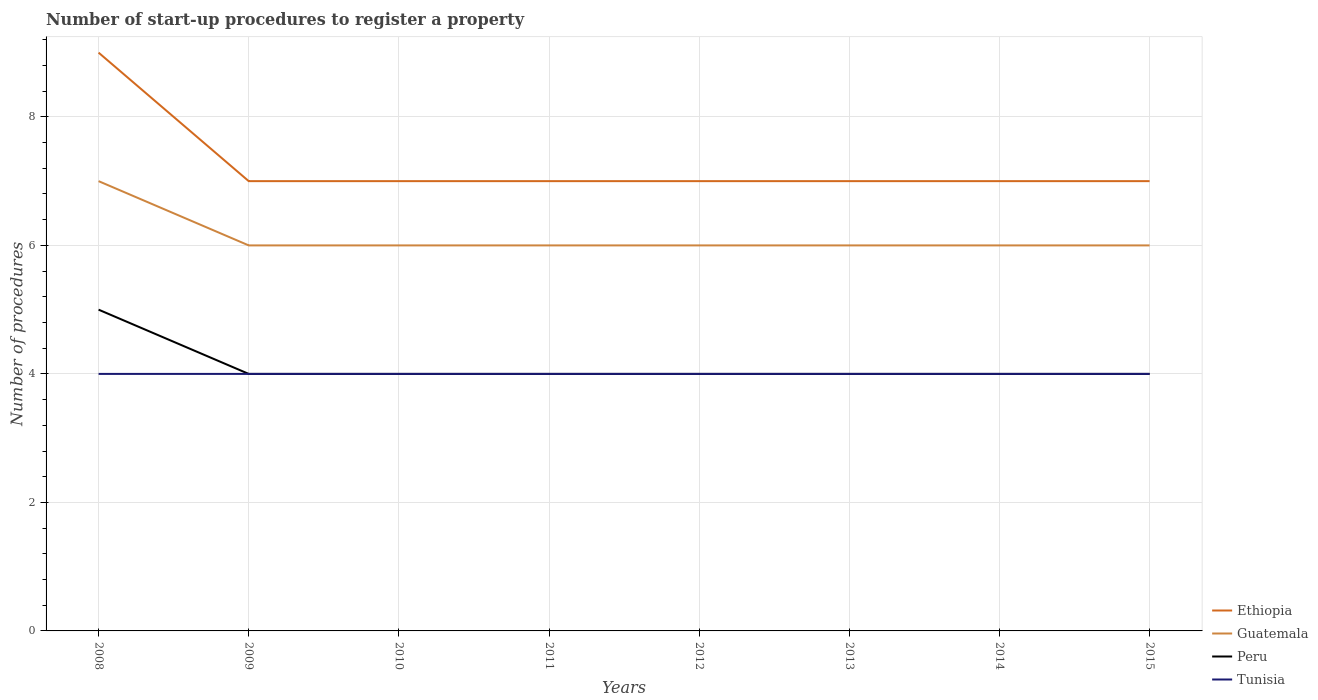How many different coloured lines are there?
Offer a terse response. 4. Across all years, what is the maximum number of procedures required to register a property in Tunisia?
Your answer should be compact. 4. What is the total number of procedures required to register a property in Ethiopia in the graph?
Give a very brief answer. 0. What is the difference between the highest and the second highest number of procedures required to register a property in Guatemala?
Your answer should be compact. 1. What is the difference between the highest and the lowest number of procedures required to register a property in Peru?
Offer a very short reply. 1. Is the number of procedures required to register a property in Guatemala strictly greater than the number of procedures required to register a property in Ethiopia over the years?
Offer a very short reply. Yes. What is the difference between two consecutive major ticks on the Y-axis?
Your response must be concise. 2. Are the values on the major ticks of Y-axis written in scientific E-notation?
Make the answer very short. No. Does the graph contain any zero values?
Offer a terse response. No. Does the graph contain grids?
Offer a very short reply. Yes. Where does the legend appear in the graph?
Your answer should be very brief. Bottom right. What is the title of the graph?
Your response must be concise. Number of start-up procedures to register a property. What is the label or title of the X-axis?
Keep it short and to the point. Years. What is the label or title of the Y-axis?
Provide a short and direct response. Number of procedures. What is the Number of procedures of Guatemala in 2008?
Ensure brevity in your answer.  7. What is the Number of procedures in Tunisia in 2008?
Keep it short and to the point. 4. What is the Number of procedures in Ethiopia in 2009?
Offer a very short reply. 7. What is the Number of procedures in Peru in 2009?
Give a very brief answer. 4. What is the Number of procedures in Tunisia in 2009?
Provide a short and direct response. 4. What is the Number of procedures in Guatemala in 2011?
Your answer should be compact. 6. What is the Number of procedures in Ethiopia in 2013?
Offer a very short reply. 7. What is the Number of procedures in Peru in 2013?
Keep it short and to the point. 4. What is the Number of procedures of Guatemala in 2014?
Offer a very short reply. 6. What is the Number of procedures in Tunisia in 2014?
Keep it short and to the point. 4. What is the Number of procedures in Ethiopia in 2015?
Your answer should be very brief. 7. What is the Number of procedures of Guatemala in 2015?
Keep it short and to the point. 6. Across all years, what is the maximum Number of procedures of Ethiopia?
Offer a terse response. 9. Across all years, what is the maximum Number of procedures in Tunisia?
Your answer should be very brief. 4. Across all years, what is the minimum Number of procedures of Ethiopia?
Offer a terse response. 7. Across all years, what is the minimum Number of procedures of Tunisia?
Keep it short and to the point. 4. What is the total Number of procedures in Ethiopia in the graph?
Ensure brevity in your answer.  58. What is the total Number of procedures of Peru in the graph?
Your response must be concise. 33. What is the total Number of procedures in Tunisia in the graph?
Provide a succinct answer. 32. What is the difference between the Number of procedures in Ethiopia in 2008 and that in 2009?
Ensure brevity in your answer.  2. What is the difference between the Number of procedures in Tunisia in 2008 and that in 2009?
Keep it short and to the point. 0. What is the difference between the Number of procedures in Ethiopia in 2008 and that in 2010?
Your answer should be very brief. 2. What is the difference between the Number of procedures in Peru in 2008 and that in 2011?
Provide a short and direct response. 1. What is the difference between the Number of procedures in Tunisia in 2008 and that in 2011?
Your answer should be very brief. 0. What is the difference between the Number of procedures in Guatemala in 2008 and that in 2012?
Give a very brief answer. 1. What is the difference between the Number of procedures of Tunisia in 2008 and that in 2012?
Provide a succinct answer. 0. What is the difference between the Number of procedures in Guatemala in 2008 and that in 2013?
Make the answer very short. 1. What is the difference between the Number of procedures of Peru in 2008 and that in 2013?
Your answer should be compact. 1. What is the difference between the Number of procedures in Guatemala in 2009 and that in 2010?
Give a very brief answer. 0. What is the difference between the Number of procedures of Peru in 2009 and that in 2010?
Your answer should be very brief. 0. What is the difference between the Number of procedures in Tunisia in 2009 and that in 2010?
Offer a very short reply. 0. What is the difference between the Number of procedures in Guatemala in 2009 and that in 2011?
Your answer should be very brief. 0. What is the difference between the Number of procedures of Ethiopia in 2009 and that in 2012?
Offer a terse response. 0. What is the difference between the Number of procedures of Tunisia in 2009 and that in 2012?
Your response must be concise. 0. What is the difference between the Number of procedures in Guatemala in 2009 and that in 2013?
Your answer should be very brief. 0. What is the difference between the Number of procedures in Guatemala in 2009 and that in 2014?
Keep it short and to the point. 0. What is the difference between the Number of procedures of Peru in 2009 and that in 2014?
Your answer should be compact. 0. What is the difference between the Number of procedures of Tunisia in 2009 and that in 2014?
Provide a short and direct response. 0. What is the difference between the Number of procedures in Ethiopia in 2009 and that in 2015?
Your response must be concise. 0. What is the difference between the Number of procedures in Peru in 2009 and that in 2015?
Give a very brief answer. 0. What is the difference between the Number of procedures in Tunisia in 2009 and that in 2015?
Offer a very short reply. 0. What is the difference between the Number of procedures of Ethiopia in 2010 and that in 2011?
Provide a succinct answer. 0. What is the difference between the Number of procedures of Guatemala in 2010 and that in 2011?
Your answer should be compact. 0. What is the difference between the Number of procedures of Peru in 2010 and that in 2011?
Offer a very short reply. 0. What is the difference between the Number of procedures in Guatemala in 2010 and that in 2012?
Ensure brevity in your answer.  0. What is the difference between the Number of procedures of Ethiopia in 2010 and that in 2013?
Ensure brevity in your answer.  0. What is the difference between the Number of procedures of Guatemala in 2010 and that in 2013?
Keep it short and to the point. 0. What is the difference between the Number of procedures in Tunisia in 2010 and that in 2013?
Your response must be concise. 0. What is the difference between the Number of procedures of Tunisia in 2010 and that in 2014?
Offer a terse response. 0. What is the difference between the Number of procedures in Peru in 2010 and that in 2015?
Ensure brevity in your answer.  0. What is the difference between the Number of procedures in Tunisia in 2010 and that in 2015?
Your answer should be compact. 0. What is the difference between the Number of procedures of Ethiopia in 2011 and that in 2012?
Your answer should be very brief. 0. What is the difference between the Number of procedures in Peru in 2011 and that in 2013?
Provide a short and direct response. 0. What is the difference between the Number of procedures of Ethiopia in 2011 and that in 2014?
Give a very brief answer. 0. What is the difference between the Number of procedures in Guatemala in 2011 and that in 2014?
Offer a terse response. 0. What is the difference between the Number of procedures of Peru in 2011 and that in 2014?
Give a very brief answer. 0. What is the difference between the Number of procedures of Ethiopia in 2011 and that in 2015?
Your answer should be compact. 0. What is the difference between the Number of procedures of Tunisia in 2011 and that in 2015?
Keep it short and to the point. 0. What is the difference between the Number of procedures of Guatemala in 2012 and that in 2013?
Your answer should be compact. 0. What is the difference between the Number of procedures in Tunisia in 2012 and that in 2013?
Your response must be concise. 0. What is the difference between the Number of procedures in Guatemala in 2012 and that in 2014?
Provide a short and direct response. 0. What is the difference between the Number of procedures in Ethiopia in 2012 and that in 2015?
Offer a very short reply. 0. What is the difference between the Number of procedures of Guatemala in 2012 and that in 2015?
Your answer should be compact. 0. What is the difference between the Number of procedures of Peru in 2013 and that in 2015?
Your response must be concise. 0. What is the difference between the Number of procedures of Guatemala in 2014 and that in 2015?
Ensure brevity in your answer.  0. What is the difference between the Number of procedures of Peru in 2014 and that in 2015?
Your response must be concise. 0. What is the difference between the Number of procedures in Tunisia in 2014 and that in 2015?
Your answer should be very brief. 0. What is the difference between the Number of procedures in Ethiopia in 2008 and the Number of procedures in Guatemala in 2009?
Your answer should be very brief. 3. What is the difference between the Number of procedures of Guatemala in 2008 and the Number of procedures of Tunisia in 2009?
Your answer should be very brief. 3. What is the difference between the Number of procedures in Peru in 2008 and the Number of procedures in Tunisia in 2009?
Offer a very short reply. 1. What is the difference between the Number of procedures in Ethiopia in 2008 and the Number of procedures in Guatemala in 2010?
Offer a terse response. 3. What is the difference between the Number of procedures in Ethiopia in 2008 and the Number of procedures in Peru in 2010?
Offer a terse response. 5. What is the difference between the Number of procedures in Peru in 2008 and the Number of procedures in Tunisia in 2010?
Provide a succinct answer. 1. What is the difference between the Number of procedures of Ethiopia in 2008 and the Number of procedures of Guatemala in 2011?
Offer a very short reply. 3. What is the difference between the Number of procedures in Ethiopia in 2008 and the Number of procedures in Peru in 2011?
Offer a very short reply. 5. What is the difference between the Number of procedures in Guatemala in 2008 and the Number of procedures in Tunisia in 2011?
Offer a terse response. 3. What is the difference between the Number of procedures of Ethiopia in 2008 and the Number of procedures of Tunisia in 2012?
Ensure brevity in your answer.  5. What is the difference between the Number of procedures of Ethiopia in 2008 and the Number of procedures of Guatemala in 2014?
Your answer should be very brief. 3. What is the difference between the Number of procedures in Guatemala in 2008 and the Number of procedures in Tunisia in 2014?
Keep it short and to the point. 3. What is the difference between the Number of procedures of Peru in 2008 and the Number of procedures of Tunisia in 2014?
Give a very brief answer. 1. What is the difference between the Number of procedures in Guatemala in 2008 and the Number of procedures in Tunisia in 2015?
Give a very brief answer. 3. What is the difference between the Number of procedures of Peru in 2008 and the Number of procedures of Tunisia in 2015?
Give a very brief answer. 1. What is the difference between the Number of procedures in Ethiopia in 2009 and the Number of procedures in Guatemala in 2010?
Offer a very short reply. 1. What is the difference between the Number of procedures in Guatemala in 2009 and the Number of procedures in Peru in 2010?
Your response must be concise. 2. What is the difference between the Number of procedures in Peru in 2009 and the Number of procedures in Tunisia in 2010?
Keep it short and to the point. 0. What is the difference between the Number of procedures in Ethiopia in 2009 and the Number of procedures in Tunisia in 2011?
Ensure brevity in your answer.  3. What is the difference between the Number of procedures in Guatemala in 2009 and the Number of procedures in Tunisia in 2011?
Your answer should be compact. 2. What is the difference between the Number of procedures of Peru in 2009 and the Number of procedures of Tunisia in 2011?
Give a very brief answer. 0. What is the difference between the Number of procedures in Ethiopia in 2009 and the Number of procedures in Peru in 2012?
Keep it short and to the point. 3. What is the difference between the Number of procedures in Ethiopia in 2009 and the Number of procedures in Tunisia in 2012?
Make the answer very short. 3. What is the difference between the Number of procedures in Guatemala in 2009 and the Number of procedures in Peru in 2012?
Offer a terse response. 2. What is the difference between the Number of procedures of Guatemala in 2009 and the Number of procedures of Tunisia in 2012?
Provide a short and direct response. 2. What is the difference between the Number of procedures in Peru in 2009 and the Number of procedures in Tunisia in 2012?
Keep it short and to the point. 0. What is the difference between the Number of procedures of Ethiopia in 2009 and the Number of procedures of Guatemala in 2013?
Make the answer very short. 1. What is the difference between the Number of procedures of Guatemala in 2009 and the Number of procedures of Tunisia in 2013?
Ensure brevity in your answer.  2. What is the difference between the Number of procedures of Peru in 2009 and the Number of procedures of Tunisia in 2013?
Your answer should be compact. 0. What is the difference between the Number of procedures of Ethiopia in 2009 and the Number of procedures of Guatemala in 2014?
Give a very brief answer. 1. What is the difference between the Number of procedures in Ethiopia in 2009 and the Number of procedures in Peru in 2014?
Offer a terse response. 3. What is the difference between the Number of procedures of Ethiopia in 2009 and the Number of procedures of Tunisia in 2014?
Provide a short and direct response. 3. What is the difference between the Number of procedures of Guatemala in 2009 and the Number of procedures of Peru in 2014?
Offer a terse response. 2. What is the difference between the Number of procedures in Guatemala in 2009 and the Number of procedures in Tunisia in 2014?
Make the answer very short. 2. What is the difference between the Number of procedures of Peru in 2009 and the Number of procedures of Tunisia in 2014?
Offer a very short reply. 0. What is the difference between the Number of procedures in Ethiopia in 2009 and the Number of procedures in Peru in 2015?
Your answer should be compact. 3. What is the difference between the Number of procedures in Guatemala in 2009 and the Number of procedures in Peru in 2015?
Provide a short and direct response. 2. What is the difference between the Number of procedures of Peru in 2009 and the Number of procedures of Tunisia in 2015?
Make the answer very short. 0. What is the difference between the Number of procedures in Ethiopia in 2010 and the Number of procedures in Peru in 2011?
Provide a succinct answer. 3. What is the difference between the Number of procedures of Ethiopia in 2010 and the Number of procedures of Tunisia in 2011?
Your answer should be very brief. 3. What is the difference between the Number of procedures in Guatemala in 2010 and the Number of procedures in Peru in 2011?
Give a very brief answer. 2. What is the difference between the Number of procedures of Guatemala in 2010 and the Number of procedures of Tunisia in 2011?
Offer a terse response. 2. What is the difference between the Number of procedures in Peru in 2010 and the Number of procedures in Tunisia in 2011?
Your answer should be compact. 0. What is the difference between the Number of procedures of Ethiopia in 2010 and the Number of procedures of Peru in 2012?
Keep it short and to the point. 3. What is the difference between the Number of procedures of Ethiopia in 2010 and the Number of procedures of Guatemala in 2013?
Offer a very short reply. 1. What is the difference between the Number of procedures in Guatemala in 2010 and the Number of procedures in Tunisia in 2013?
Your response must be concise. 2. What is the difference between the Number of procedures of Peru in 2010 and the Number of procedures of Tunisia in 2013?
Make the answer very short. 0. What is the difference between the Number of procedures in Ethiopia in 2010 and the Number of procedures in Peru in 2014?
Your response must be concise. 3. What is the difference between the Number of procedures of Ethiopia in 2010 and the Number of procedures of Tunisia in 2014?
Ensure brevity in your answer.  3. What is the difference between the Number of procedures in Guatemala in 2010 and the Number of procedures in Peru in 2014?
Keep it short and to the point. 2. What is the difference between the Number of procedures in Ethiopia in 2010 and the Number of procedures in Guatemala in 2015?
Provide a succinct answer. 1. What is the difference between the Number of procedures in Ethiopia in 2010 and the Number of procedures in Peru in 2015?
Your response must be concise. 3. What is the difference between the Number of procedures in Ethiopia in 2011 and the Number of procedures in Guatemala in 2012?
Provide a succinct answer. 1. What is the difference between the Number of procedures of Ethiopia in 2011 and the Number of procedures of Peru in 2012?
Make the answer very short. 3. What is the difference between the Number of procedures of Guatemala in 2011 and the Number of procedures of Peru in 2012?
Your answer should be very brief. 2. What is the difference between the Number of procedures of Peru in 2011 and the Number of procedures of Tunisia in 2012?
Give a very brief answer. 0. What is the difference between the Number of procedures of Ethiopia in 2011 and the Number of procedures of Peru in 2013?
Offer a terse response. 3. What is the difference between the Number of procedures in Guatemala in 2011 and the Number of procedures in Peru in 2013?
Your answer should be very brief. 2. What is the difference between the Number of procedures of Guatemala in 2011 and the Number of procedures of Tunisia in 2013?
Offer a terse response. 2. What is the difference between the Number of procedures in Guatemala in 2011 and the Number of procedures in Tunisia in 2014?
Give a very brief answer. 2. What is the difference between the Number of procedures in Peru in 2011 and the Number of procedures in Tunisia in 2014?
Make the answer very short. 0. What is the difference between the Number of procedures in Guatemala in 2011 and the Number of procedures in Peru in 2015?
Your response must be concise. 2. What is the difference between the Number of procedures of Peru in 2011 and the Number of procedures of Tunisia in 2015?
Your answer should be very brief. 0. What is the difference between the Number of procedures in Ethiopia in 2012 and the Number of procedures in Guatemala in 2013?
Ensure brevity in your answer.  1. What is the difference between the Number of procedures of Ethiopia in 2012 and the Number of procedures of Peru in 2013?
Give a very brief answer. 3. What is the difference between the Number of procedures in Guatemala in 2012 and the Number of procedures in Peru in 2013?
Ensure brevity in your answer.  2. What is the difference between the Number of procedures in Guatemala in 2012 and the Number of procedures in Tunisia in 2013?
Make the answer very short. 2. What is the difference between the Number of procedures in Ethiopia in 2012 and the Number of procedures in Tunisia in 2014?
Keep it short and to the point. 3. What is the difference between the Number of procedures in Peru in 2012 and the Number of procedures in Tunisia in 2014?
Your answer should be very brief. 0. What is the difference between the Number of procedures in Ethiopia in 2012 and the Number of procedures in Tunisia in 2015?
Offer a very short reply. 3. What is the difference between the Number of procedures in Peru in 2012 and the Number of procedures in Tunisia in 2015?
Make the answer very short. 0. What is the difference between the Number of procedures in Ethiopia in 2013 and the Number of procedures in Peru in 2014?
Keep it short and to the point. 3. What is the difference between the Number of procedures of Guatemala in 2013 and the Number of procedures of Peru in 2014?
Make the answer very short. 2. What is the difference between the Number of procedures in Ethiopia in 2013 and the Number of procedures in Tunisia in 2015?
Give a very brief answer. 3. What is the difference between the Number of procedures in Guatemala in 2013 and the Number of procedures in Peru in 2015?
Your response must be concise. 2. What is the difference between the Number of procedures in Guatemala in 2013 and the Number of procedures in Tunisia in 2015?
Provide a succinct answer. 2. What is the difference between the Number of procedures of Ethiopia in 2014 and the Number of procedures of Guatemala in 2015?
Your response must be concise. 1. What is the difference between the Number of procedures of Guatemala in 2014 and the Number of procedures of Peru in 2015?
Your answer should be compact. 2. What is the difference between the Number of procedures of Guatemala in 2014 and the Number of procedures of Tunisia in 2015?
Your answer should be compact. 2. What is the average Number of procedures of Ethiopia per year?
Offer a terse response. 7.25. What is the average Number of procedures in Guatemala per year?
Keep it short and to the point. 6.12. What is the average Number of procedures of Peru per year?
Make the answer very short. 4.12. In the year 2008, what is the difference between the Number of procedures in Ethiopia and Number of procedures in Guatemala?
Give a very brief answer. 2. In the year 2008, what is the difference between the Number of procedures of Ethiopia and Number of procedures of Peru?
Your answer should be very brief. 4. In the year 2008, what is the difference between the Number of procedures in Ethiopia and Number of procedures in Tunisia?
Your answer should be compact. 5. In the year 2009, what is the difference between the Number of procedures of Ethiopia and Number of procedures of Guatemala?
Provide a short and direct response. 1. In the year 2009, what is the difference between the Number of procedures of Guatemala and Number of procedures of Peru?
Your response must be concise. 2. In the year 2009, what is the difference between the Number of procedures in Guatemala and Number of procedures in Tunisia?
Give a very brief answer. 2. In the year 2010, what is the difference between the Number of procedures of Ethiopia and Number of procedures of Guatemala?
Give a very brief answer. 1. In the year 2010, what is the difference between the Number of procedures in Ethiopia and Number of procedures in Tunisia?
Offer a very short reply. 3. In the year 2010, what is the difference between the Number of procedures of Guatemala and Number of procedures of Peru?
Your answer should be compact. 2. In the year 2010, what is the difference between the Number of procedures of Peru and Number of procedures of Tunisia?
Your answer should be very brief. 0. In the year 2011, what is the difference between the Number of procedures in Guatemala and Number of procedures in Peru?
Your response must be concise. 2. In the year 2011, what is the difference between the Number of procedures of Guatemala and Number of procedures of Tunisia?
Your answer should be very brief. 2. In the year 2011, what is the difference between the Number of procedures in Peru and Number of procedures in Tunisia?
Provide a succinct answer. 0. In the year 2012, what is the difference between the Number of procedures in Ethiopia and Number of procedures in Peru?
Your answer should be compact. 3. In the year 2012, what is the difference between the Number of procedures of Ethiopia and Number of procedures of Tunisia?
Your answer should be very brief. 3. In the year 2012, what is the difference between the Number of procedures of Guatemala and Number of procedures of Peru?
Provide a short and direct response. 2. In the year 2012, what is the difference between the Number of procedures in Guatemala and Number of procedures in Tunisia?
Keep it short and to the point. 2. In the year 2012, what is the difference between the Number of procedures of Peru and Number of procedures of Tunisia?
Give a very brief answer. 0. In the year 2013, what is the difference between the Number of procedures in Ethiopia and Number of procedures in Tunisia?
Provide a short and direct response. 3. In the year 2013, what is the difference between the Number of procedures in Guatemala and Number of procedures in Tunisia?
Offer a very short reply. 2. In the year 2014, what is the difference between the Number of procedures of Ethiopia and Number of procedures of Peru?
Offer a terse response. 3. In the year 2014, what is the difference between the Number of procedures in Ethiopia and Number of procedures in Tunisia?
Give a very brief answer. 3. In the year 2014, what is the difference between the Number of procedures in Guatemala and Number of procedures in Peru?
Your response must be concise. 2. In the year 2014, what is the difference between the Number of procedures in Peru and Number of procedures in Tunisia?
Ensure brevity in your answer.  0. In the year 2015, what is the difference between the Number of procedures in Ethiopia and Number of procedures in Peru?
Your answer should be compact. 3. In the year 2015, what is the difference between the Number of procedures of Peru and Number of procedures of Tunisia?
Your response must be concise. 0. What is the ratio of the Number of procedures of Guatemala in 2008 to that in 2009?
Give a very brief answer. 1.17. What is the ratio of the Number of procedures of Peru in 2008 to that in 2009?
Your answer should be very brief. 1.25. What is the ratio of the Number of procedures of Ethiopia in 2008 to that in 2010?
Keep it short and to the point. 1.29. What is the ratio of the Number of procedures of Guatemala in 2008 to that in 2010?
Offer a very short reply. 1.17. What is the ratio of the Number of procedures of Peru in 2008 to that in 2010?
Offer a terse response. 1.25. What is the ratio of the Number of procedures of Tunisia in 2008 to that in 2010?
Provide a succinct answer. 1. What is the ratio of the Number of procedures of Ethiopia in 2008 to that in 2011?
Your response must be concise. 1.29. What is the ratio of the Number of procedures of Peru in 2008 to that in 2012?
Ensure brevity in your answer.  1.25. What is the ratio of the Number of procedures in Tunisia in 2008 to that in 2012?
Your answer should be very brief. 1. What is the ratio of the Number of procedures in Guatemala in 2008 to that in 2013?
Make the answer very short. 1.17. What is the ratio of the Number of procedures in Ethiopia in 2008 to that in 2015?
Your answer should be very brief. 1.29. What is the ratio of the Number of procedures in Peru in 2008 to that in 2015?
Ensure brevity in your answer.  1.25. What is the ratio of the Number of procedures of Guatemala in 2009 to that in 2010?
Your answer should be very brief. 1. What is the ratio of the Number of procedures of Ethiopia in 2009 to that in 2011?
Ensure brevity in your answer.  1. What is the ratio of the Number of procedures of Peru in 2009 to that in 2011?
Provide a short and direct response. 1. What is the ratio of the Number of procedures of Tunisia in 2009 to that in 2011?
Offer a very short reply. 1. What is the ratio of the Number of procedures in Guatemala in 2009 to that in 2012?
Keep it short and to the point. 1. What is the ratio of the Number of procedures of Peru in 2009 to that in 2012?
Make the answer very short. 1. What is the ratio of the Number of procedures of Tunisia in 2009 to that in 2012?
Give a very brief answer. 1. What is the ratio of the Number of procedures of Guatemala in 2009 to that in 2013?
Your answer should be very brief. 1. What is the ratio of the Number of procedures of Peru in 2009 to that in 2013?
Make the answer very short. 1. What is the ratio of the Number of procedures of Tunisia in 2009 to that in 2013?
Provide a short and direct response. 1. What is the ratio of the Number of procedures in Ethiopia in 2009 to that in 2014?
Provide a succinct answer. 1. What is the ratio of the Number of procedures in Guatemala in 2009 to that in 2014?
Provide a succinct answer. 1. What is the ratio of the Number of procedures in Tunisia in 2009 to that in 2014?
Make the answer very short. 1. What is the ratio of the Number of procedures of Ethiopia in 2009 to that in 2015?
Ensure brevity in your answer.  1. What is the ratio of the Number of procedures of Guatemala in 2010 to that in 2011?
Keep it short and to the point. 1. What is the ratio of the Number of procedures of Tunisia in 2010 to that in 2011?
Your answer should be very brief. 1. What is the ratio of the Number of procedures of Guatemala in 2010 to that in 2012?
Provide a succinct answer. 1. What is the ratio of the Number of procedures of Tunisia in 2010 to that in 2012?
Your answer should be compact. 1. What is the ratio of the Number of procedures of Tunisia in 2010 to that in 2013?
Ensure brevity in your answer.  1. What is the ratio of the Number of procedures in Tunisia in 2010 to that in 2014?
Your response must be concise. 1. What is the ratio of the Number of procedures in Ethiopia in 2010 to that in 2015?
Offer a terse response. 1. What is the ratio of the Number of procedures in Guatemala in 2010 to that in 2015?
Make the answer very short. 1. What is the ratio of the Number of procedures in Ethiopia in 2011 to that in 2012?
Provide a short and direct response. 1. What is the ratio of the Number of procedures of Ethiopia in 2011 to that in 2013?
Offer a terse response. 1. What is the ratio of the Number of procedures of Guatemala in 2011 to that in 2013?
Give a very brief answer. 1. What is the ratio of the Number of procedures in Peru in 2011 to that in 2013?
Provide a succinct answer. 1. What is the ratio of the Number of procedures in Tunisia in 2011 to that in 2013?
Offer a very short reply. 1. What is the ratio of the Number of procedures of Ethiopia in 2011 to that in 2014?
Provide a succinct answer. 1. What is the ratio of the Number of procedures of Guatemala in 2011 to that in 2014?
Offer a terse response. 1. What is the ratio of the Number of procedures of Peru in 2011 to that in 2014?
Your answer should be compact. 1. What is the ratio of the Number of procedures in Guatemala in 2011 to that in 2015?
Provide a succinct answer. 1. What is the ratio of the Number of procedures in Peru in 2011 to that in 2015?
Make the answer very short. 1. What is the ratio of the Number of procedures of Tunisia in 2012 to that in 2013?
Provide a short and direct response. 1. What is the ratio of the Number of procedures in Ethiopia in 2012 to that in 2014?
Keep it short and to the point. 1. What is the ratio of the Number of procedures in Peru in 2012 to that in 2014?
Your answer should be compact. 1. What is the ratio of the Number of procedures of Tunisia in 2012 to that in 2014?
Give a very brief answer. 1. What is the ratio of the Number of procedures in Peru in 2012 to that in 2015?
Your answer should be very brief. 1. What is the ratio of the Number of procedures in Tunisia in 2012 to that in 2015?
Your answer should be very brief. 1. What is the ratio of the Number of procedures in Ethiopia in 2013 to that in 2014?
Provide a succinct answer. 1. What is the ratio of the Number of procedures in Tunisia in 2013 to that in 2014?
Offer a terse response. 1. What is the ratio of the Number of procedures of Ethiopia in 2013 to that in 2015?
Give a very brief answer. 1. What is the ratio of the Number of procedures of Peru in 2014 to that in 2015?
Keep it short and to the point. 1. What is the difference between the highest and the second highest Number of procedures in Guatemala?
Give a very brief answer. 1. What is the difference between the highest and the lowest Number of procedures of Ethiopia?
Give a very brief answer. 2. What is the difference between the highest and the lowest Number of procedures in Guatemala?
Give a very brief answer. 1. 